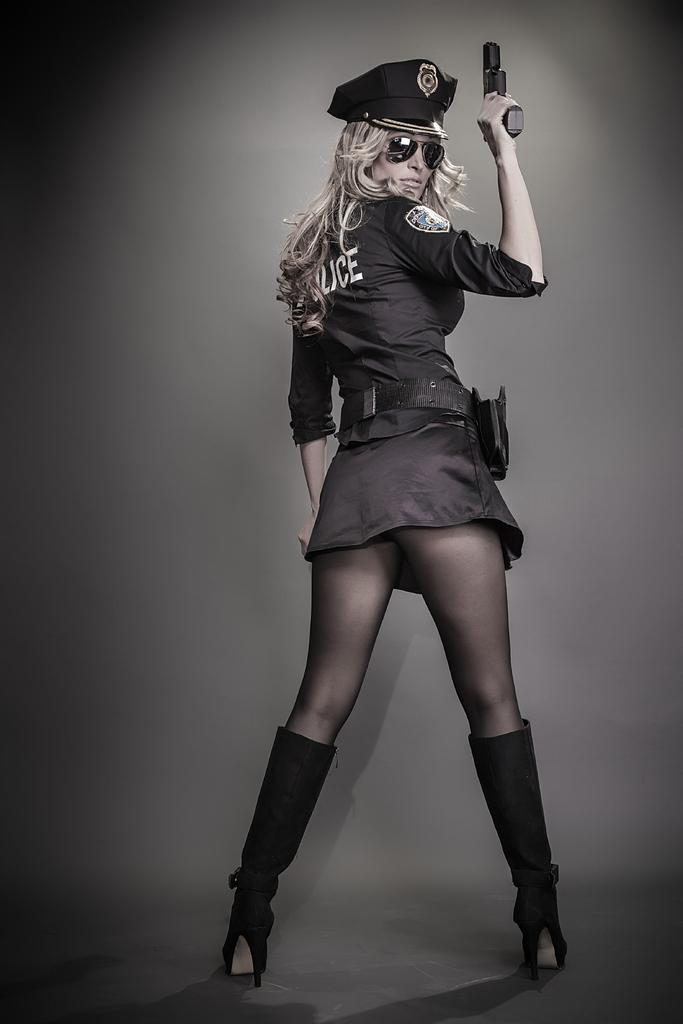Who is the main subject in the image? There is a woman in the image. What is the woman doing in the image? The woman is standing over a place. What type of uniform is the woman wearing? The woman is wearing a police uniform. What is the woman holding in the image? The woman is holding a gun. What protective gear is the woman wearing? The woman is wearing goggles. What type of headwear is the woman wearing? The woman is wearing a cap. What type of soda is the woman drinking in the image? There is no soda present in the image. Is there a playground visible in the background of the image? There is no playground mentioned or visible in the image. 